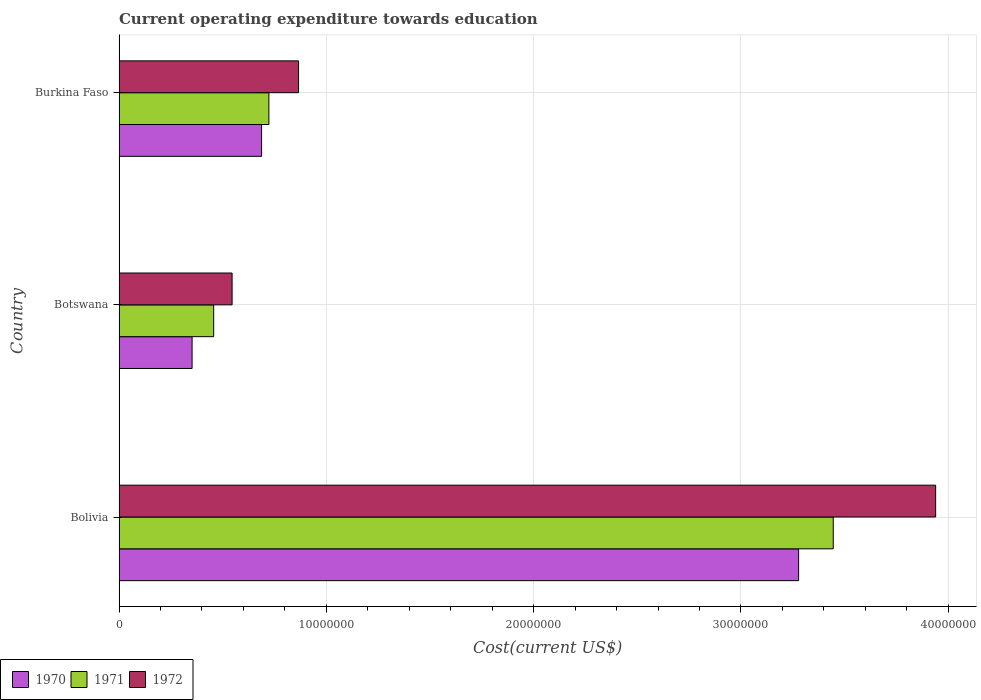How many different coloured bars are there?
Make the answer very short. 3. How many groups of bars are there?
Offer a very short reply. 3. Are the number of bars per tick equal to the number of legend labels?
Provide a short and direct response. Yes. What is the label of the 1st group of bars from the top?
Offer a very short reply. Burkina Faso. What is the expenditure towards education in 1972 in Bolivia?
Your response must be concise. 3.94e+07. Across all countries, what is the maximum expenditure towards education in 1971?
Provide a succinct answer. 3.45e+07. Across all countries, what is the minimum expenditure towards education in 1970?
Give a very brief answer. 3.52e+06. In which country was the expenditure towards education in 1972 minimum?
Keep it short and to the point. Botswana. What is the total expenditure towards education in 1971 in the graph?
Provide a succinct answer. 4.62e+07. What is the difference between the expenditure towards education in 1971 in Botswana and that in Burkina Faso?
Provide a short and direct response. -2.66e+06. What is the difference between the expenditure towards education in 1971 in Burkina Faso and the expenditure towards education in 1972 in Botswana?
Ensure brevity in your answer.  1.78e+06. What is the average expenditure towards education in 1970 per country?
Your answer should be very brief. 1.44e+07. What is the difference between the expenditure towards education in 1972 and expenditure towards education in 1970 in Burkina Faso?
Offer a terse response. 1.78e+06. What is the ratio of the expenditure towards education in 1972 in Botswana to that in Burkina Faso?
Provide a short and direct response. 0.63. Is the difference between the expenditure towards education in 1972 in Bolivia and Burkina Faso greater than the difference between the expenditure towards education in 1970 in Bolivia and Burkina Faso?
Keep it short and to the point. Yes. What is the difference between the highest and the second highest expenditure towards education in 1972?
Offer a terse response. 3.07e+07. What is the difference between the highest and the lowest expenditure towards education in 1970?
Keep it short and to the point. 2.93e+07. In how many countries, is the expenditure towards education in 1970 greater than the average expenditure towards education in 1970 taken over all countries?
Make the answer very short. 1. What does the 2nd bar from the top in Botswana represents?
Your answer should be compact. 1971. Does the graph contain grids?
Offer a very short reply. Yes. How are the legend labels stacked?
Your response must be concise. Horizontal. What is the title of the graph?
Ensure brevity in your answer.  Current operating expenditure towards education. What is the label or title of the X-axis?
Ensure brevity in your answer.  Cost(current US$). What is the label or title of the Y-axis?
Keep it short and to the point. Country. What is the Cost(current US$) of 1970 in Bolivia?
Provide a short and direct response. 3.28e+07. What is the Cost(current US$) of 1971 in Bolivia?
Give a very brief answer. 3.45e+07. What is the Cost(current US$) of 1972 in Bolivia?
Your answer should be very brief. 3.94e+07. What is the Cost(current US$) of 1970 in Botswana?
Keep it short and to the point. 3.52e+06. What is the Cost(current US$) of 1971 in Botswana?
Provide a short and direct response. 4.56e+06. What is the Cost(current US$) of 1972 in Botswana?
Offer a terse response. 5.45e+06. What is the Cost(current US$) of 1970 in Burkina Faso?
Make the answer very short. 6.88e+06. What is the Cost(current US$) of 1971 in Burkina Faso?
Offer a terse response. 7.23e+06. What is the Cost(current US$) in 1972 in Burkina Faso?
Provide a short and direct response. 8.66e+06. Across all countries, what is the maximum Cost(current US$) of 1970?
Offer a terse response. 3.28e+07. Across all countries, what is the maximum Cost(current US$) of 1971?
Give a very brief answer. 3.45e+07. Across all countries, what is the maximum Cost(current US$) in 1972?
Keep it short and to the point. 3.94e+07. Across all countries, what is the minimum Cost(current US$) of 1970?
Make the answer very short. 3.52e+06. Across all countries, what is the minimum Cost(current US$) in 1971?
Make the answer very short. 4.56e+06. Across all countries, what is the minimum Cost(current US$) in 1972?
Your answer should be very brief. 5.45e+06. What is the total Cost(current US$) in 1970 in the graph?
Ensure brevity in your answer.  4.32e+07. What is the total Cost(current US$) in 1971 in the graph?
Your answer should be very brief. 4.62e+07. What is the total Cost(current US$) in 1972 in the graph?
Give a very brief answer. 5.35e+07. What is the difference between the Cost(current US$) of 1970 in Bolivia and that in Botswana?
Make the answer very short. 2.93e+07. What is the difference between the Cost(current US$) in 1971 in Bolivia and that in Botswana?
Offer a very short reply. 2.99e+07. What is the difference between the Cost(current US$) of 1972 in Bolivia and that in Botswana?
Keep it short and to the point. 3.39e+07. What is the difference between the Cost(current US$) in 1970 in Bolivia and that in Burkina Faso?
Give a very brief answer. 2.59e+07. What is the difference between the Cost(current US$) of 1971 in Bolivia and that in Burkina Faso?
Your answer should be compact. 2.72e+07. What is the difference between the Cost(current US$) in 1972 in Bolivia and that in Burkina Faso?
Your response must be concise. 3.07e+07. What is the difference between the Cost(current US$) of 1970 in Botswana and that in Burkina Faso?
Offer a terse response. -3.35e+06. What is the difference between the Cost(current US$) in 1971 in Botswana and that in Burkina Faso?
Keep it short and to the point. -2.66e+06. What is the difference between the Cost(current US$) of 1972 in Botswana and that in Burkina Faso?
Keep it short and to the point. -3.21e+06. What is the difference between the Cost(current US$) in 1970 in Bolivia and the Cost(current US$) in 1971 in Botswana?
Keep it short and to the point. 2.82e+07. What is the difference between the Cost(current US$) in 1970 in Bolivia and the Cost(current US$) in 1972 in Botswana?
Make the answer very short. 2.73e+07. What is the difference between the Cost(current US$) of 1971 in Bolivia and the Cost(current US$) of 1972 in Botswana?
Provide a succinct answer. 2.90e+07. What is the difference between the Cost(current US$) of 1970 in Bolivia and the Cost(current US$) of 1971 in Burkina Faso?
Offer a terse response. 2.56e+07. What is the difference between the Cost(current US$) in 1970 in Bolivia and the Cost(current US$) in 1972 in Burkina Faso?
Provide a short and direct response. 2.41e+07. What is the difference between the Cost(current US$) of 1971 in Bolivia and the Cost(current US$) of 1972 in Burkina Faso?
Offer a very short reply. 2.58e+07. What is the difference between the Cost(current US$) in 1970 in Botswana and the Cost(current US$) in 1971 in Burkina Faso?
Provide a short and direct response. -3.71e+06. What is the difference between the Cost(current US$) in 1970 in Botswana and the Cost(current US$) in 1972 in Burkina Faso?
Offer a terse response. -5.14e+06. What is the difference between the Cost(current US$) in 1971 in Botswana and the Cost(current US$) in 1972 in Burkina Faso?
Give a very brief answer. -4.09e+06. What is the average Cost(current US$) in 1970 per country?
Offer a very short reply. 1.44e+07. What is the average Cost(current US$) of 1971 per country?
Your response must be concise. 1.54e+07. What is the average Cost(current US$) in 1972 per country?
Offer a terse response. 1.78e+07. What is the difference between the Cost(current US$) of 1970 and Cost(current US$) of 1971 in Bolivia?
Offer a terse response. -1.67e+06. What is the difference between the Cost(current US$) of 1970 and Cost(current US$) of 1972 in Bolivia?
Give a very brief answer. -6.61e+06. What is the difference between the Cost(current US$) in 1971 and Cost(current US$) in 1972 in Bolivia?
Provide a short and direct response. -4.94e+06. What is the difference between the Cost(current US$) of 1970 and Cost(current US$) of 1971 in Botswana?
Your answer should be very brief. -1.04e+06. What is the difference between the Cost(current US$) in 1970 and Cost(current US$) in 1972 in Botswana?
Offer a terse response. -1.93e+06. What is the difference between the Cost(current US$) in 1971 and Cost(current US$) in 1972 in Botswana?
Your answer should be very brief. -8.89e+05. What is the difference between the Cost(current US$) in 1970 and Cost(current US$) in 1971 in Burkina Faso?
Offer a terse response. -3.53e+05. What is the difference between the Cost(current US$) in 1970 and Cost(current US$) in 1972 in Burkina Faso?
Your answer should be very brief. -1.78e+06. What is the difference between the Cost(current US$) in 1971 and Cost(current US$) in 1972 in Burkina Faso?
Provide a short and direct response. -1.43e+06. What is the ratio of the Cost(current US$) of 1970 in Bolivia to that in Botswana?
Give a very brief answer. 9.3. What is the ratio of the Cost(current US$) of 1971 in Bolivia to that in Botswana?
Give a very brief answer. 7.55. What is the ratio of the Cost(current US$) in 1972 in Bolivia to that in Botswana?
Offer a very short reply. 7.22. What is the ratio of the Cost(current US$) in 1970 in Bolivia to that in Burkina Faso?
Ensure brevity in your answer.  4.77. What is the ratio of the Cost(current US$) in 1971 in Bolivia to that in Burkina Faso?
Offer a terse response. 4.77. What is the ratio of the Cost(current US$) of 1972 in Bolivia to that in Burkina Faso?
Offer a terse response. 4.55. What is the ratio of the Cost(current US$) in 1970 in Botswana to that in Burkina Faso?
Keep it short and to the point. 0.51. What is the ratio of the Cost(current US$) in 1971 in Botswana to that in Burkina Faso?
Offer a very short reply. 0.63. What is the ratio of the Cost(current US$) of 1972 in Botswana to that in Burkina Faso?
Provide a short and direct response. 0.63. What is the difference between the highest and the second highest Cost(current US$) in 1970?
Offer a terse response. 2.59e+07. What is the difference between the highest and the second highest Cost(current US$) in 1971?
Your response must be concise. 2.72e+07. What is the difference between the highest and the second highest Cost(current US$) in 1972?
Offer a terse response. 3.07e+07. What is the difference between the highest and the lowest Cost(current US$) of 1970?
Provide a short and direct response. 2.93e+07. What is the difference between the highest and the lowest Cost(current US$) in 1971?
Provide a succinct answer. 2.99e+07. What is the difference between the highest and the lowest Cost(current US$) of 1972?
Provide a succinct answer. 3.39e+07. 